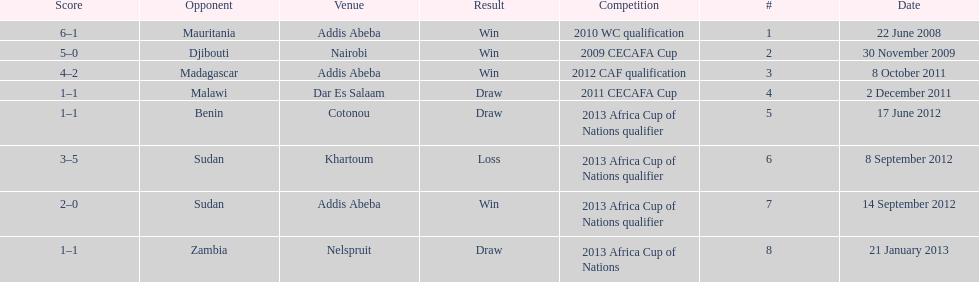What date gives was their only loss? 8 September 2012. 